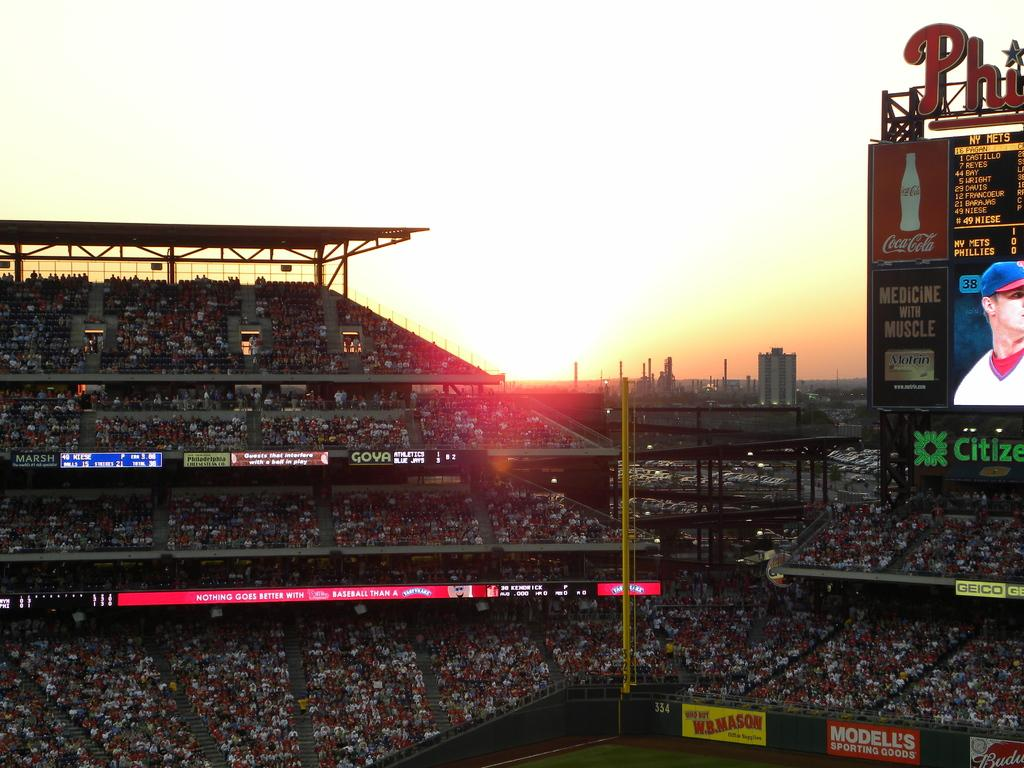<image>
Give a short and clear explanation of the subsequent image. A stadium full of people with an electronic billboard that incldes an ad for Motrin. 